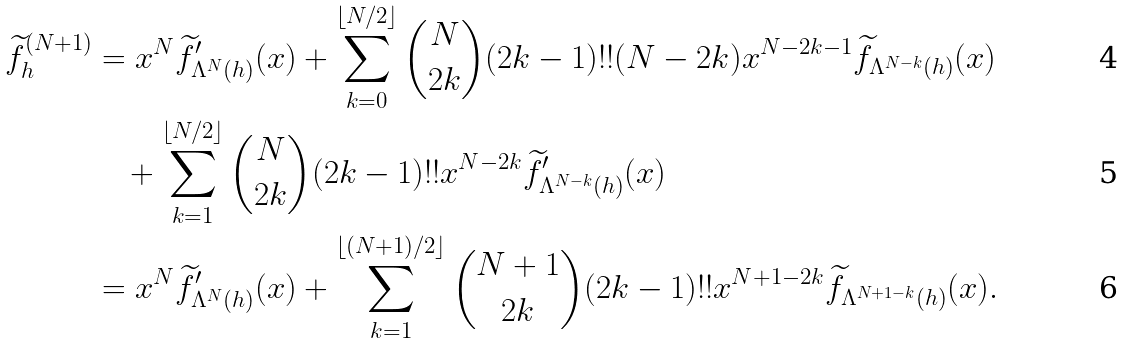Convert formula to latex. <formula><loc_0><loc_0><loc_500><loc_500>\widetilde { f } ^ { ( N + 1 ) } _ { h } & = x ^ { N } \widetilde { f } ^ { \prime } _ { \Lambda ^ { N } ( h ) } ( x ) + \sum _ { k = 0 } ^ { \lfloor N / 2 \rfloor } \binom { N } { 2 k } ( 2 k - 1 ) ! ! ( N - 2 k ) x ^ { N - 2 k - 1 } \widetilde { f } _ { \Lambda ^ { N - k } ( h ) } ( x ) \\ & \quad + \sum _ { k = 1 } ^ { \lfloor N / 2 \rfloor } \binom { N } { 2 k } ( 2 k - 1 ) ! ! x ^ { N - 2 k } \widetilde { f } ^ { \prime } _ { \Lambda ^ { N - k } ( h ) } ( x ) \\ & = x ^ { N } \widetilde { f } ^ { \prime } _ { \Lambda ^ { N } ( h ) } ( x ) + \sum _ { k = 1 } ^ { \lfloor ( N + 1 ) / 2 \rfloor } \binom { N + 1 } { 2 k } ( 2 k - 1 ) ! ! x ^ { N + 1 - 2 k } \widetilde { f } _ { \Lambda ^ { N + 1 - k } ( h ) } ( x ) .</formula> 